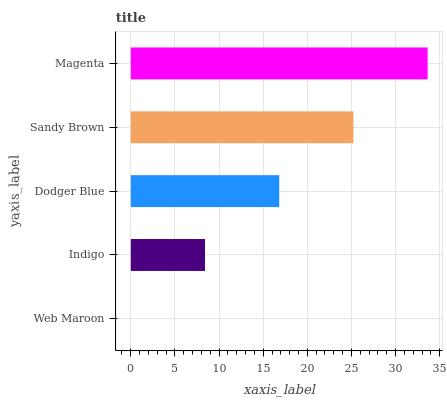Is Web Maroon the minimum?
Answer yes or no. Yes. Is Magenta the maximum?
Answer yes or no. Yes. Is Indigo the minimum?
Answer yes or no. No. Is Indigo the maximum?
Answer yes or no. No. Is Indigo greater than Web Maroon?
Answer yes or no. Yes. Is Web Maroon less than Indigo?
Answer yes or no. Yes. Is Web Maroon greater than Indigo?
Answer yes or no. No. Is Indigo less than Web Maroon?
Answer yes or no. No. Is Dodger Blue the high median?
Answer yes or no. Yes. Is Dodger Blue the low median?
Answer yes or no. Yes. Is Web Maroon the high median?
Answer yes or no. No. Is Indigo the low median?
Answer yes or no. No. 